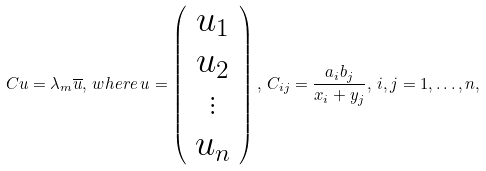<formula> <loc_0><loc_0><loc_500><loc_500>C u = \lambda _ { m } \overline { u } , \, w h e r e \, u = \left ( \begin{array} { c } u _ { 1 } \\ u _ { 2 } \\ \vdots \\ u _ { n } \end{array} \right ) , \, C _ { i j } = \frac { a _ { i } b _ { j } } { x _ { i } + y _ { j } } , \, i , j = 1 , \dots , n ,</formula> 